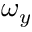<formula> <loc_0><loc_0><loc_500><loc_500>\omega _ { y }</formula> 